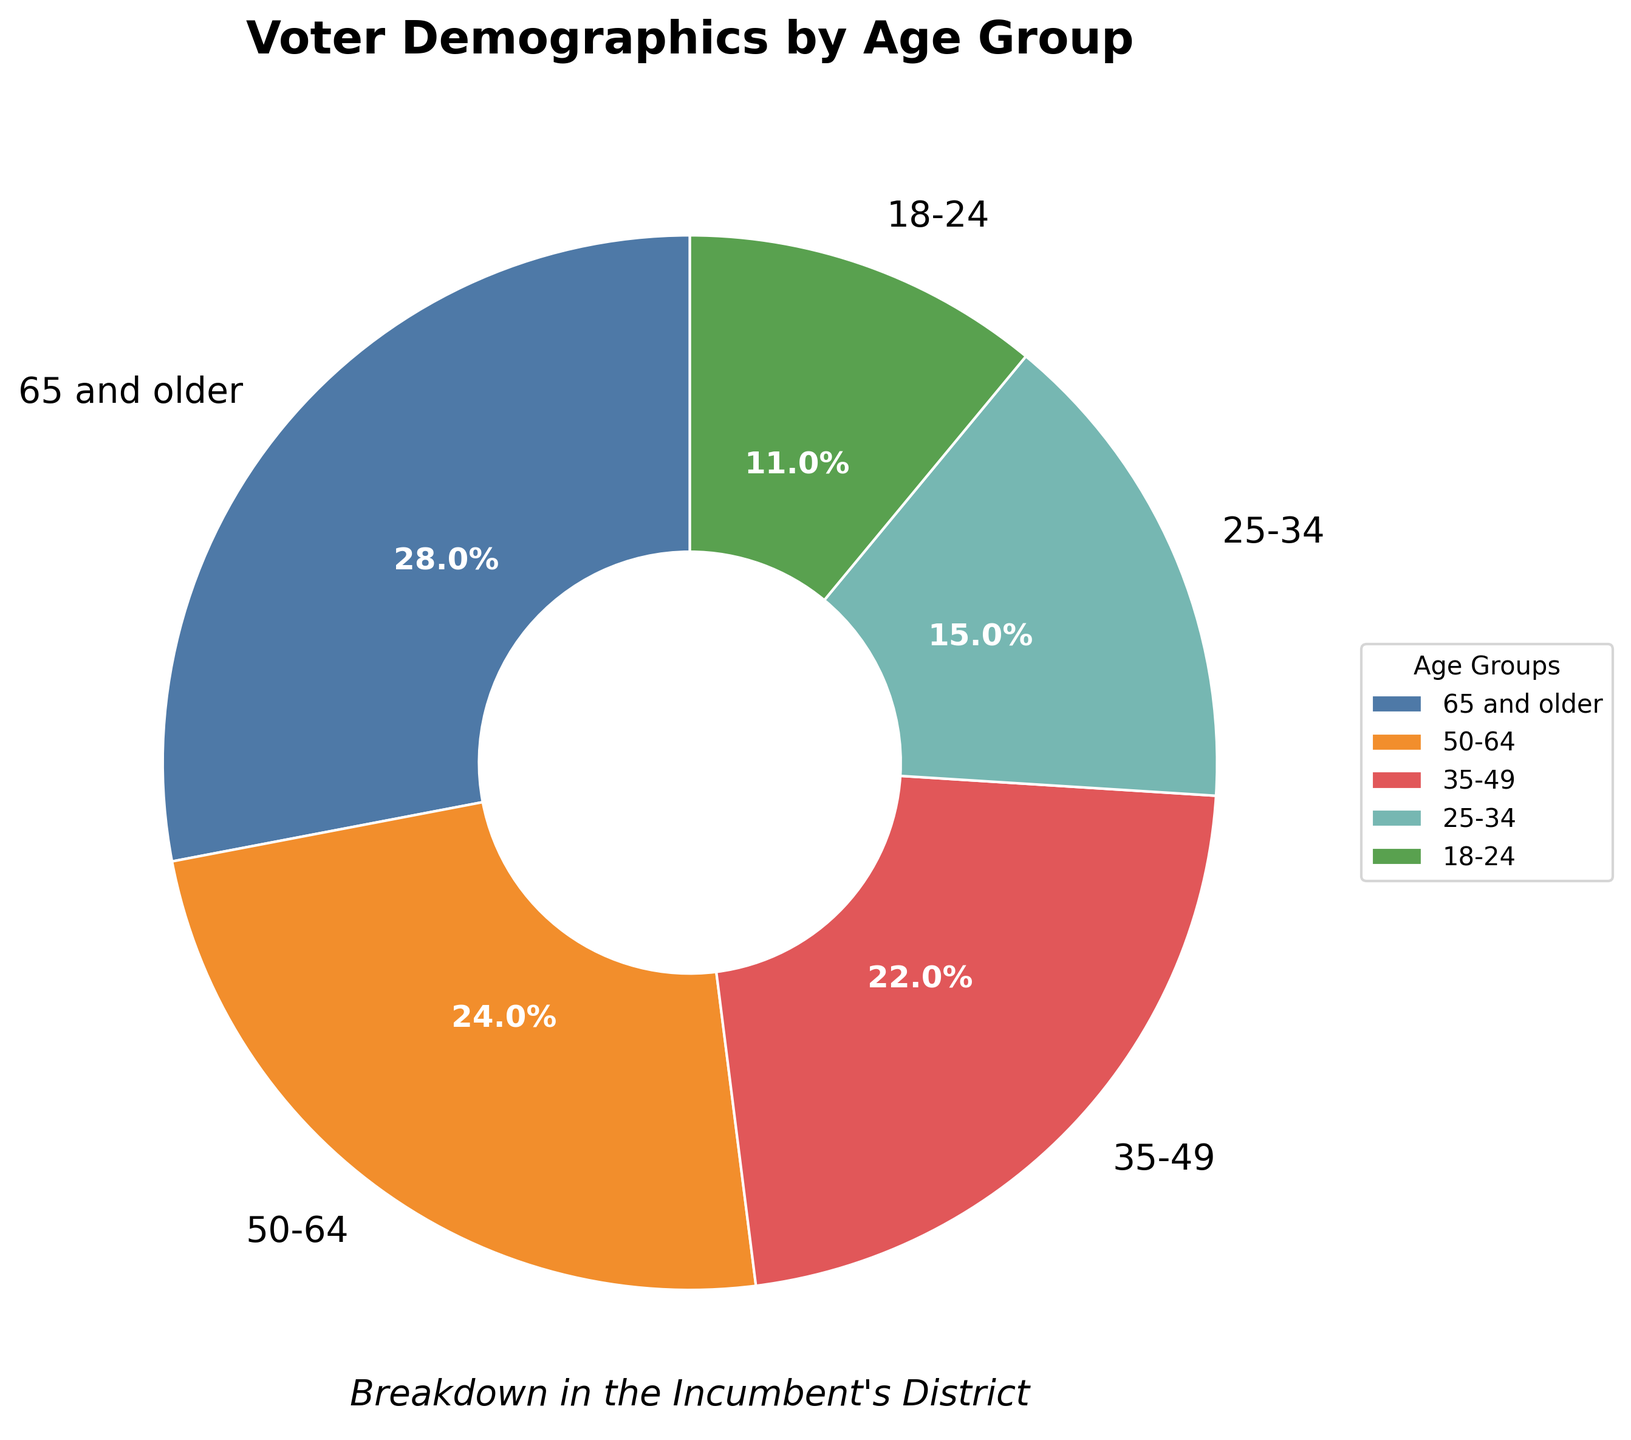What percentage of the voters are aged 35-49? To find the percentage of voters aged 35-49, locate the 35-49 age group label in the pie chart and read the corresponding percentage value.
Answer: 22% Which age group has the largest share of voters? To determine the age group with the largest share, compare the percentage values of all age groups and identify the highest one.
Answer: 65 and older How much larger is the 65 and older group compared to the 18-24 group? Locate the percentage of the 65 and older group (28%) and the 18-24 group (11%), then subtract the latter from the former: 28% - 11% = 17%
Answer: 17% What is the combined percentage of voters aged 50 and older? Add the percentages of the age groups 50-64 and 65 and older: 24% + 28% = 52%
Answer: 52% Which two age groups have a combined percentage closest to 50%? Calculate the sums of all possible pairs of age groups, and find the pair whose sum is closest to 50%. The pairs are: 65 and older + 18-24 (28% + 11%), 65 and older + 25-34 (28% + 15%), 50-64 + 35-49 (24% + 22%), etc. The closest sum is 50-64 + 35-49 (24% + 22% = 46%).
Answer: 50-64 and 35-49 How does the percentage of the 25-34 group compare to the 35-49 group? Subtract the percentage of the 25-34 group (15%) from the 35-49 group (22%): 22% - 15% = 7%. This tells us that the 35-49 group has 7% more voters than the 25-34 group.
Answer: 7% What do the colors represent in the pie chart? Identify what each color signifies by matching the colors to the age group labels in the chart's legend.
Answer: Age groups Is the percentage of voters aged 50-64 greater than those aged 18-24? Compare the percentages of voters aged 50-64 (24%) and 18-24 (11%). Since 24% is greater than 11%, the answer is yes.
Answer: Yes 